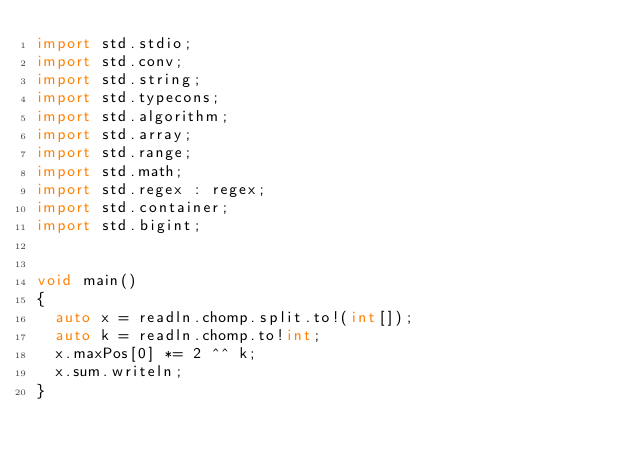<code> <loc_0><loc_0><loc_500><loc_500><_D_>import std.stdio;
import std.conv;
import std.string;
import std.typecons;
import std.algorithm;
import std.array;
import std.range;
import std.math;
import std.regex : regex;
import std.container;
import std.bigint;


void main()
{
  auto x = readln.chomp.split.to!(int[]);
  auto k = readln.chomp.to!int;
  x.maxPos[0] *= 2 ^^ k;
  x.sum.writeln;
}
</code> 